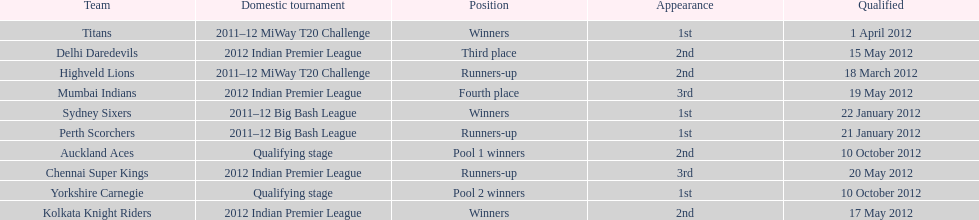On which date did the auckland aces and yorkshire carnegie qualify? 10 October 2012. 